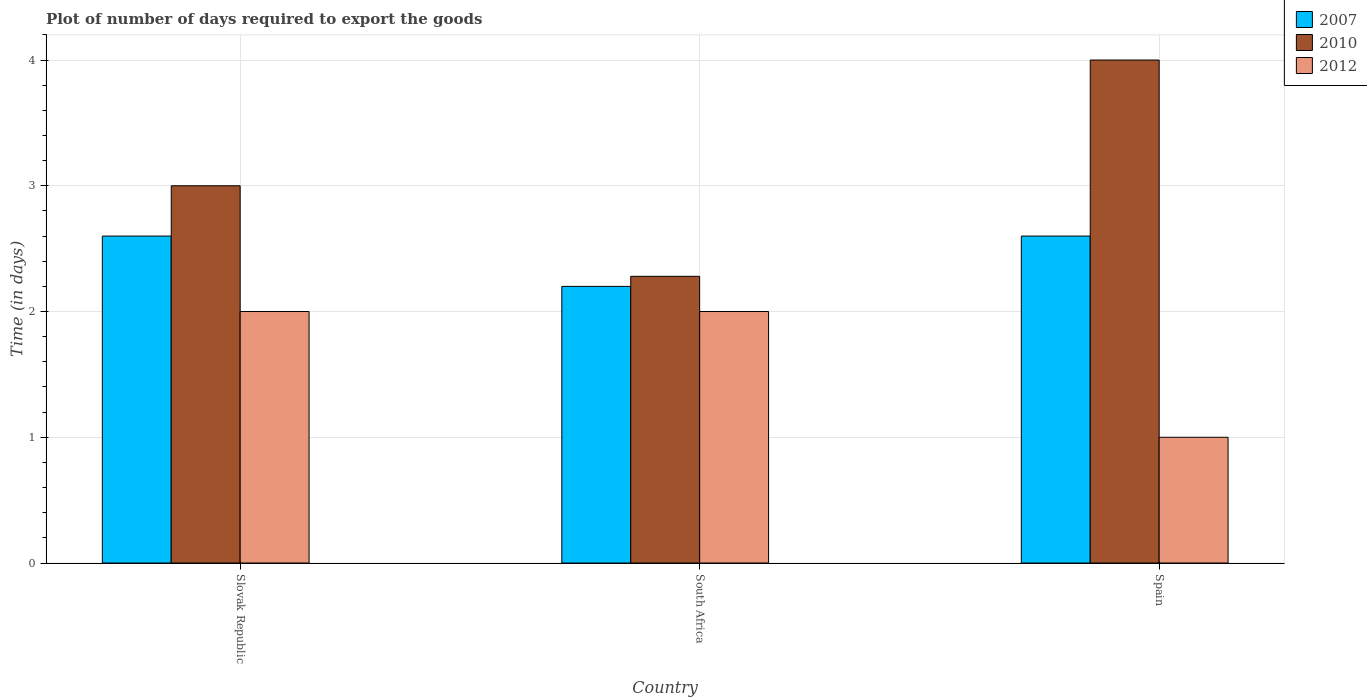How many different coloured bars are there?
Offer a terse response. 3. How many groups of bars are there?
Your answer should be very brief. 3. Are the number of bars per tick equal to the number of legend labels?
Provide a short and direct response. Yes. Are the number of bars on each tick of the X-axis equal?
Make the answer very short. Yes. How many bars are there on the 1st tick from the left?
Offer a very short reply. 3. How many bars are there on the 3rd tick from the right?
Offer a very short reply. 3. What is the label of the 1st group of bars from the left?
Ensure brevity in your answer.  Slovak Republic. What is the time required to export goods in 2010 in South Africa?
Make the answer very short. 2.28. Across all countries, what is the minimum time required to export goods in 2012?
Your answer should be compact. 1. In which country was the time required to export goods in 2012 maximum?
Your response must be concise. Slovak Republic. In which country was the time required to export goods in 2010 minimum?
Provide a short and direct response. South Africa. What is the difference between the time required to export goods in 2007 in Slovak Republic and the time required to export goods in 2010 in South Africa?
Make the answer very short. 0.32. What is the average time required to export goods in 2007 per country?
Offer a very short reply. 2.47. What is the difference between the time required to export goods of/in 2007 and time required to export goods of/in 2010 in Spain?
Ensure brevity in your answer.  -1.4. What is the ratio of the time required to export goods in 2010 in South Africa to that in Spain?
Ensure brevity in your answer.  0.57. Is the time required to export goods in 2010 in South Africa less than that in Spain?
Keep it short and to the point. Yes. Is the difference between the time required to export goods in 2007 in South Africa and Spain greater than the difference between the time required to export goods in 2010 in South Africa and Spain?
Offer a terse response. Yes. Are all the bars in the graph horizontal?
Keep it short and to the point. No. What is the difference between two consecutive major ticks on the Y-axis?
Provide a succinct answer. 1. Where does the legend appear in the graph?
Provide a succinct answer. Top right. How many legend labels are there?
Provide a short and direct response. 3. What is the title of the graph?
Offer a very short reply. Plot of number of days required to export the goods. Does "1977" appear as one of the legend labels in the graph?
Provide a succinct answer. No. What is the label or title of the Y-axis?
Offer a very short reply. Time (in days). What is the Time (in days) in 2010 in South Africa?
Your answer should be compact. 2.28. What is the Time (in days) in 2012 in South Africa?
Give a very brief answer. 2. What is the Time (in days) in 2007 in Spain?
Offer a very short reply. 2.6. What is the Time (in days) of 2010 in Spain?
Make the answer very short. 4. What is the Time (in days) in 2012 in Spain?
Give a very brief answer. 1. Across all countries, what is the minimum Time (in days) in 2010?
Give a very brief answer. 2.28. Across all countries, what is the minimum Time (in days) in 2012?
Give a very brief answer. 1. What is the total Time (in days) in 2010 in the graph?
Offer a terse response. 9.28. What is the difference between the Time (in days) in 2007 in Slovak Republic and that in South Africa?
Give a very brief answer. 0.4. What is the difference between the Time (in days) in 2010 in Slovak Republic and that in South Africa?
Make the answer very short. 0.72. What is the difference between the Time (in days) in 2012 in Slovak Republic and that in South Africa?
Your response must be concise. 0. What is the difference between the Time (in days) of 2007 in Slovak Republic and that in Spain?
Make the answer very short. 0. What is the difference between the Time (in days) of 2007 in South Africa and that in Spain?
Give a very brief answer. -0.4. What is the difference between the Time (in days) in 2010 in South Africa and that in Spain?
Provide a succinct answer. -1.72. What is the difference between the Time (in days) of 2007 in Slovak Republic and the Time (in days) of 2010 in South Africa?
Your answer should be compact. 0.32. What is the difference between the Time (in days) of 2010 in Slovak Republic and the Time (in days) of 2012 in South Africa?
Your answer should be compact. 1. What is the difference between the Time (in days) in 2010 in Slovak Republic and the Time (in days) in 2012 in Spain?
Your answer should be very brief. 2. What is the difference between the Time (in days) in 2007 in South Africa and the Time (in days) in 2012 in Spain?
Ensure brevity in your answer.  1.2. What is the difference between the Time (in days) of 2010 in South Africa and the Time (in days) of 2012 in Spain?
Offer a very short reply. 1.28. What is the average Time (in days) of 2007 per country?
Give a very brief answer. 2.47. What is the average Time (in days) of 2010 per country?
Offer a terse response. 3.09. What is the difference between the Time (in days) in 2007 and Time (in days) in 2010 in Slovak Republic?
Give a very brief answer. -0.4. What is the difference between the Time (in days) in 2010 and Time (in days) in 2012 in Slovak Republic?
Keep it short and to the point. 1. What is the difference between the Time (in days) in 2007 and Time (in days) in 2010 in South Africa?
Your answer should be compact. -0.08. What is the difference between the Time (in days) of 2010 and Time (in days) of 2012 in South Africa?
Your response must be concise. 0.28. What is the difference between the Time (in days) in 2007 and Time (in days) in 2012 in Spain?
Your answer should be compact. 1.6. What is the difference between the Time (in days) in 2010 and Time (in days) in 2012 in Spain?
Make the answer very short. 3. What is the ratio of the Time (in days) of 2007 in Slovak Republic to that in South Africa?
Make the answer very short. 1.18. What is the ratio of the Time (in days) of 2010 in Slovak Republic to that in South Africa?
Provide a succinct answer. 1.32. What is the ratio of the Time (in days) of 2012 in Slovak Republic to that in South Africa?
Ensure brevity in your answer.  1. What is the ratio of the Time (in days) of 2007 in Slovak Republic to that in Spain?
Keep it short and to the point. 1. What is the ratio of the Time (in days) in 2007 in South Africa to that in Spain?
Give a very brief answer. 0.85. What is the ratio of the Time (in days) of 2010 in South Africa to that in Spain?
Offer a terse response. 0.57. What is the ratio of the Time (in days) of 2012 in South Africa to that in Spain?
Make the answer very short. 2. What is the difference between the highest and the second highest Time (in days) in 2007?
Offer a terse response. 0. What is the difference between the highest and the second highest Time (in days) in 2010?
Ensure brevity in your answer.  1. What is the difference between the highest and the second highest Time (in days) in 2012?
Provide a succinct answer. 0. What is the difference between the highest and the lowest Time (in days) of 2007?
Your answer should be very brief. 0.4. What is the difference between the highest and the lowest Time (in days) in 2010?
Your response must be concise. 1.72. What is the difference between the highest and the lowest Time (in days) in 2012?
Offer a terse response. 1. 